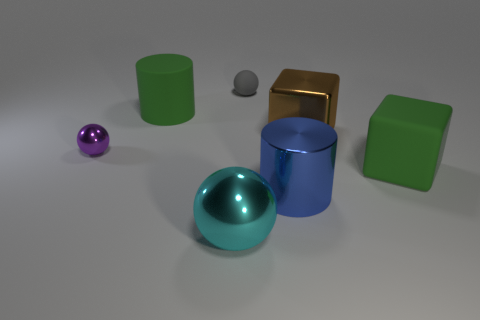There is a large blue thing; what number of blue metal things are in front of it?
Offer a terse response. 0. Are there fewer small shiny objects behind the shiny cylinder than cyan spheres to the right of the matte cube?
Provide a succinct answer. No. What is the shape of the green rubber object that is on the left side of the big object that is in front of the large shiny cylinder that is right of the gray matte ball?
Your answer should be very brief. Cylinder. The object that is right of the big blue object and in front of the tiny purple metal object has what shape?
Give a very brief answer. Cube. Is there a small cyan thing made of the same material as the large sphere?
Your response must be concise. No. What is the size of the block that is the same color as the large matte cylinder?
Your response must be concise. Large. What color is the large object in front of the large blue shiny object?
Ensure brevity in your answer.  Cyan. There is a gray object; does it have the same shape as the green rubber thing that is behind the big brown thing?
Your response must be concise. No. Is there a object of the same color as the small metal sphere?
Give a very brief answer. No. What is the size of the purple thing that is the same material as the brown thing?
Ensure brevity in your answer.  Small. 